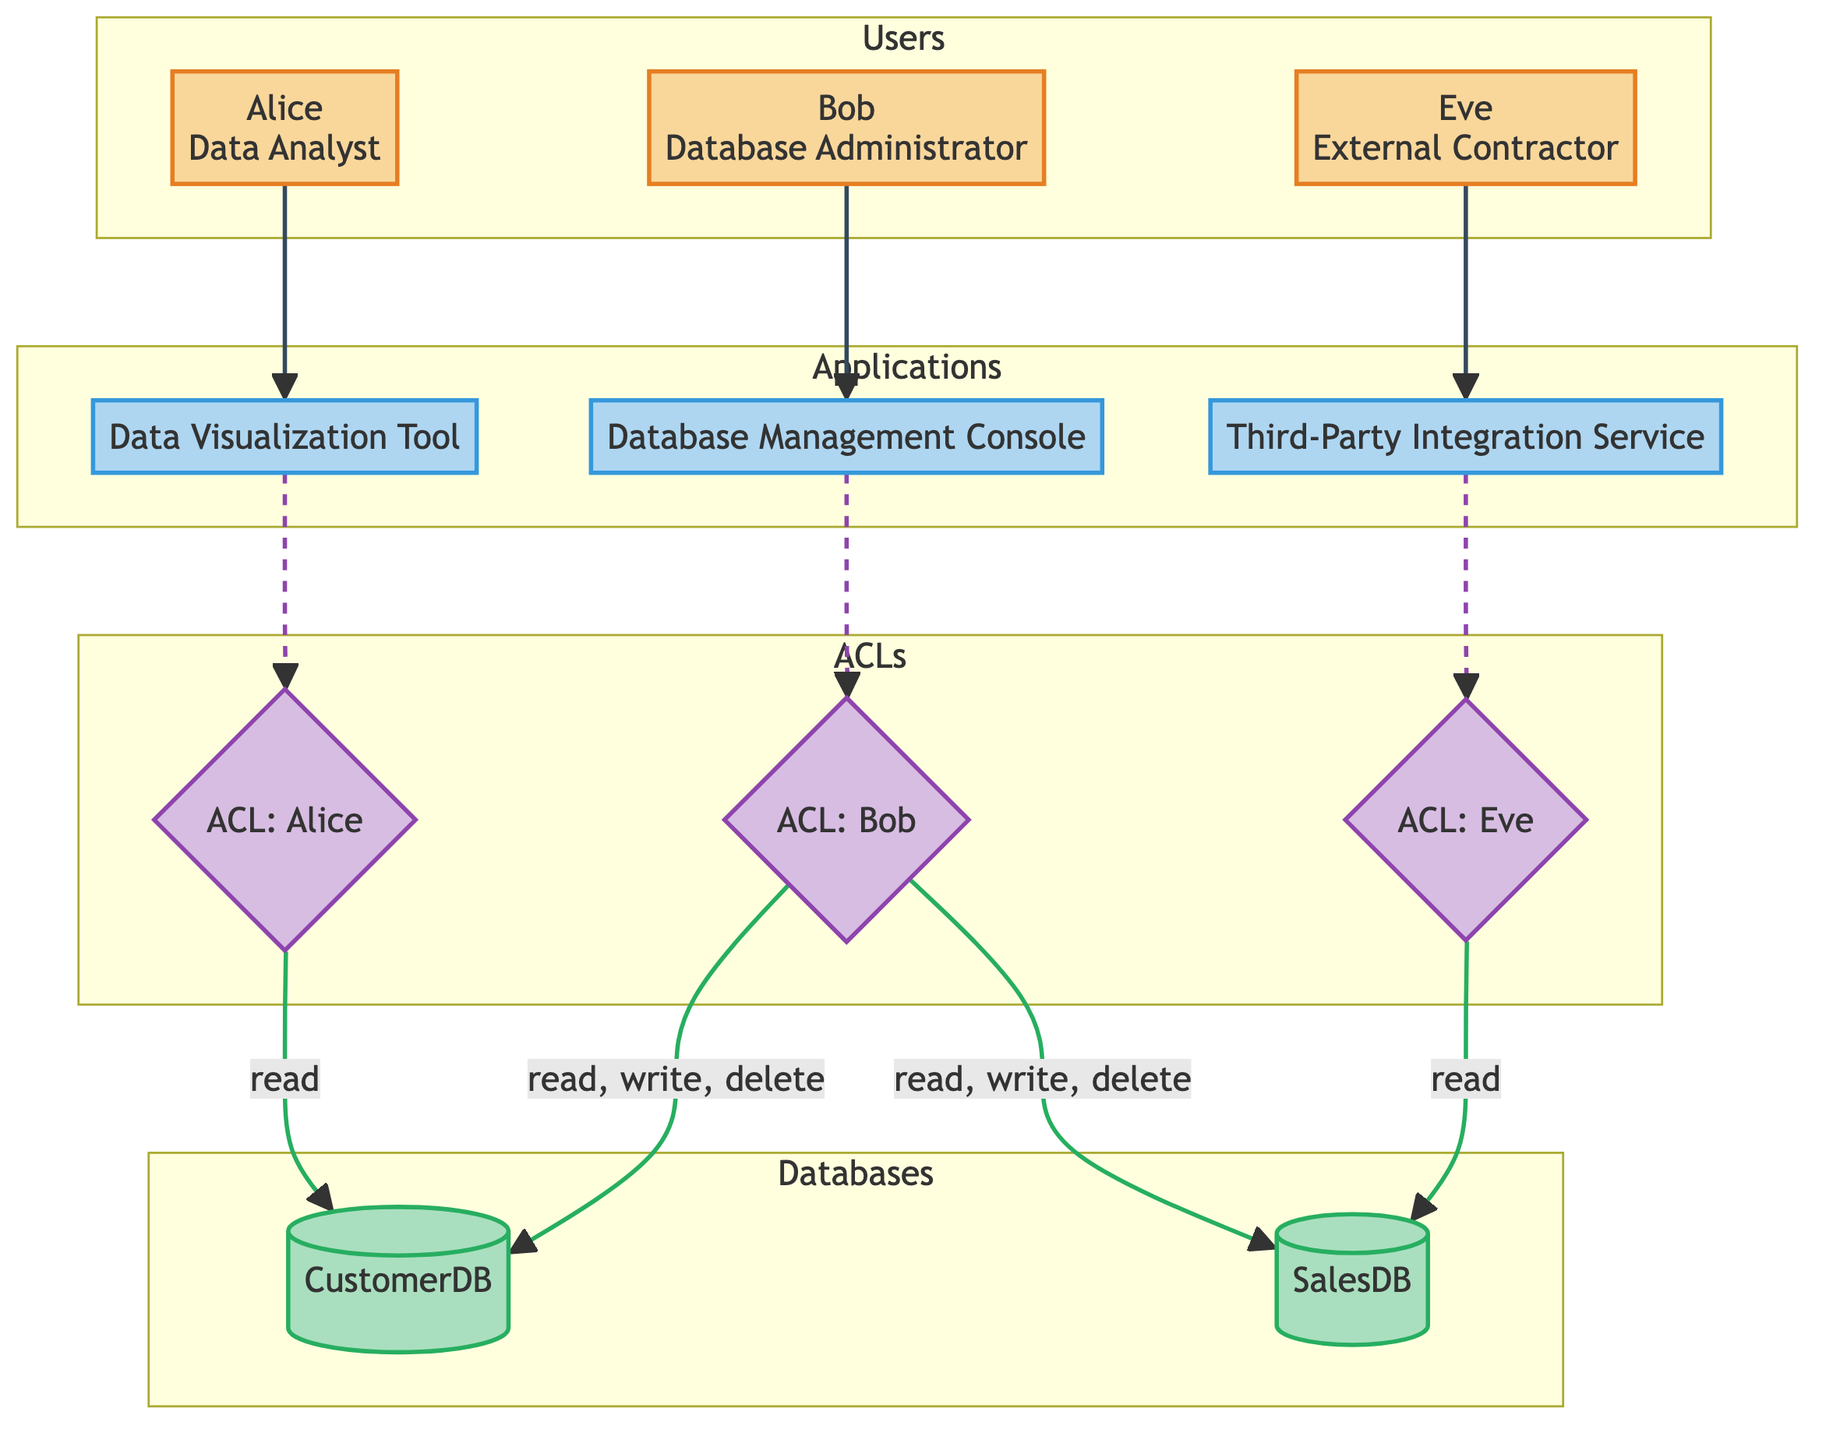What are the roles of the users depicted in the diagram? The diagram clearly lists each user's role next to their name. Alice is categorized as a Data Analyst, Bob is a Database Administrator, and Eve is an External Contractor.
Answer: Data Analyst, Database Administrator, External Contractor How many users are present in the diagram? Counting the number of user nodes in the diagram, we can identify that there are three users listed: Alice, Bob, and Eve.
Answer: 3 Which database can the Database Administrator read, write, and delete from? The user Bob, who is a Database Administrator, has permissions to read, write, and delete from both CustomerDB and SalesDB.
Answer: CustomerDB, SalesDB What type of access does the External Contractor have on SalesDB? According to the diagram, the External Contractor, Eve, has read access to SalesDB, indicated by the ACL linked to her.
Answer: read Which application is associated with Alice? The diagram connects Alice, who is a Data Analyst, to the Data Visualization Tool, indicating this application is used by her.
Answer: Data Visualization Tool What is the relationship between the Database Management Console and the Database Administrator? The Database Management Console is connected directly to Bob, confirming that the Database Administrator is the user accessing this application.
Answer: Direct connection How many databases are shown in the diagram? By inspecting the database section of the diagram, we can see it contains two databases: CustomerDB and SalesDB.
Answer: 2 What type of permissions does Alice have on CustomerDB according to the ACL? The ACL for Alice indicates she has read access to CustomerDB, which is specifically outlined in the permissions section of the diagram.
Answer: read Which user has permissions to read, write, and delete in both databases? The permissions outlined for Bob, the Database Administrator, specify that he can read, write, and delete in both CustomerDB and SalesDB.
Answer: Bob 